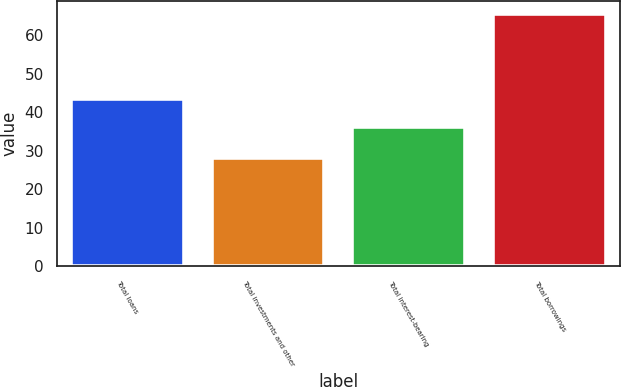<chart> <loc_0><loc_0><loc_500><loc_500><bar_chart><fcel>Total loans<fcel>Total investments and other<fcel>Total interest-bearing<fcel>Total borrowings<nl><fcel>43.5<fcel>28.2<fcel>36.3<fcel>65.6<nl></chart> 